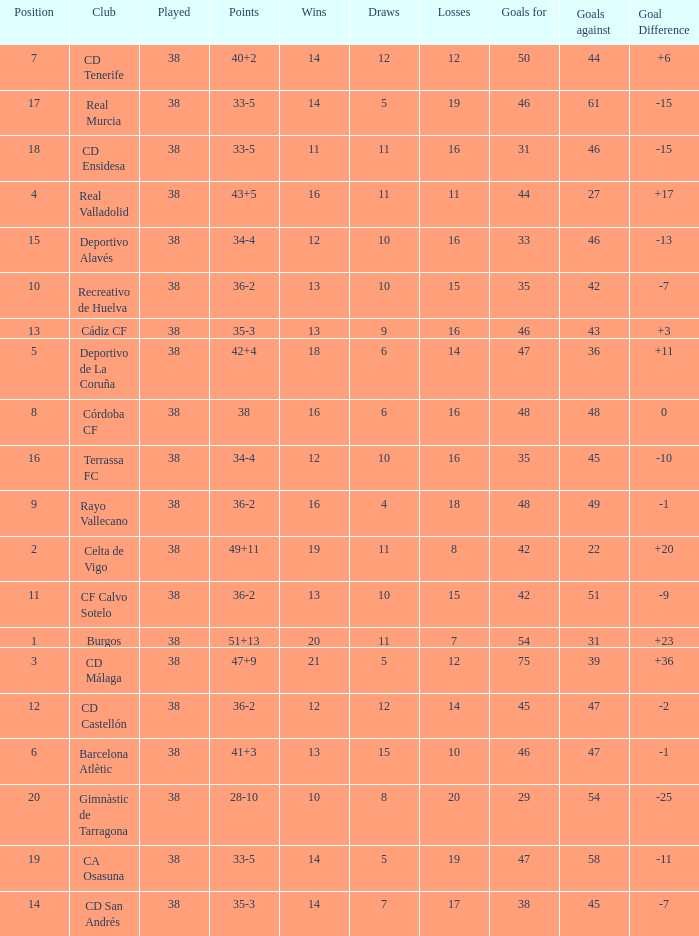What is the average loss with a goal higher than 51 and wins higher than 14? None. Would you be able to parse every entry in this table? {'header': ['Position', 'Club', 'Played', 'Points', 'Wins', 'Draws', 'Losses', 'Goals for', 'Goals against', 'Goal Difference'], 'rows': [['7', 'CD Tenerife', '38', '40+2', '14', '12', '12', '50', '44', '+6'], ['17', 'Real Murcia', '38', '33-5', '14', '5', '19', '46', '61', '-15'], ['18', 'CD Ensidesa', '38', '33-5', '11', '11', '16', '31', '46', '-15'], ['4', 'Real Valladolid', '38', '43+5', '16', '11', '11', '44', '27', '+17'], ['15', 'Deportivo Alavés', '38', '34-4', '12', '10', '16', '33', '46', '-13'], ['10', 'Recreativo de Huelva', '38', '36-2', '13', '10', '15', '35', '42', '-7'], ['13', 'Cádiz CF', '38', '35-3', '13', '9', '16', '46', '43', '+3'], ['5', 'Deportivo de La Coruña', '38', '42+4', '18', '6', '14', '47', '36', '+11'], ['8', 'Córdoba CF', '38', '38', '16', '6', '16', '48', '48', '0'], ['16', 'Terrassa FC', '38', '34-4', '12', '10', '16', '35', '45', '-10'], ['9', 'Rayo Vallecano', '38', '36-2', '16', '4', '18', '48', '49', '-1'], ['2', 'Celta de Vigo', '38', '49+11', '19', '11', '8', '42', '22', '+20'], ['11', 'CF Calvo Sotelo', '38', '36-2', '13', '10', '15', '42', '51', '-9'], ['1', 'Burgos', '38', '51+13', '20', '11', '7', '54', '31', '+23'], ['3', 'CD Málaga', '38', '47+9', '21', '5', '12', '75', '39', '+36'], ['12', 'CD Castellón', '38', '36-2', '12', '12', '14', '45', '47', '-2'], ['6', 'Barcelona Atlètic', '38', '41+3', '13', '15', '10', '46', '47', '-1'], ['20', 'Gimnàstic de Tarragona', '38', '28-10', '10', '8', '20', '29', '54', '-25'], ['19', 'CA Osasuna', '38', '33-5', '14', '5', '19', '47', '58', '-11'], ['14', 'CD San Andrés', '38', '35-3', '14', '7', '17', '38', '45', '-7']]} 